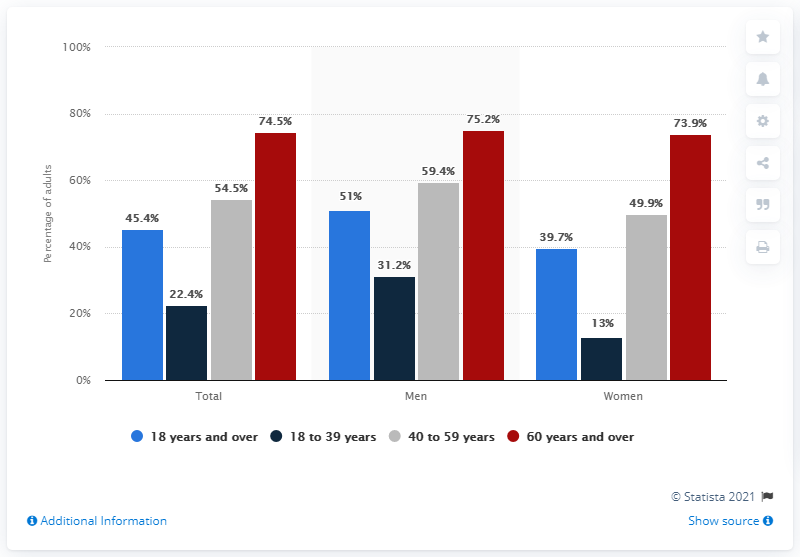Give some essential details in this illustration. The average height of all the women is 44.12 inches. The highest value in the red bar is 75.2%. 